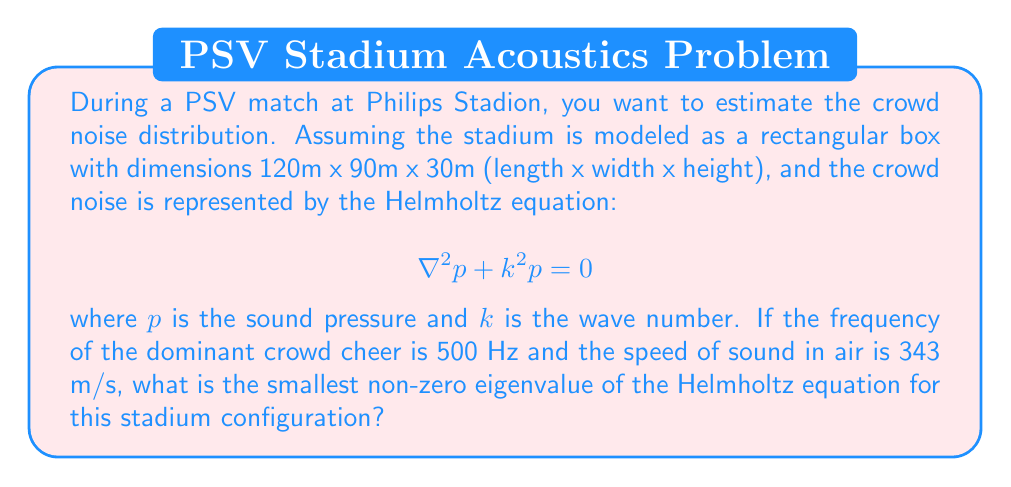Teach me how to tackle this problem. To solve this problem, we need to follow these steps:

1) First, we need to calculate the wave number $k$:
   $k = \frac{2\pi f}{c}$, where $f$ is the frequency and $c$ is the speed of sound
   $k = \frac{2\pi (500)}{343} \approx 9.16$ m^(-1)

2) The general solution for the Helmholtz equation in a rectangular box is:
   $$p(x,y,z) = A \cos(\frac{n_x \pi x}{L_x}) \cos(\frac{n_y \pi y}{L_y}) \cos(\frac{n_z \pi z}{L_z})$$
   where $L_x$, $L_y$, and $L_z$ are the dimensions of the box, and $n_x$, $n_y$, and $n_z$ are non-negative integers.

3) The eigenvalues are given by:
   $$k^2 = (\frac{n_x \pi}{L_x})^2 + (\frac{n_y \pi}{L_y})^2 + (\frac{n_z \pi}{L_z})^2$$

4) The smallest non-zero eigenvalue will occur when two of $n_x$, $n_y$, and $n_z$ are 0, and the other is 1. Since $L_z$ (height) is the smallest dimension, the smallest eigenvalue will occur when $n_z = 1$ and $n_x = n_y = 0$.

5) Therefore, the smallest non-zero eigenvalue is:
   $$k^2 = (\frac{\pi}{L_z})^2 = (\frac{\pi}{30})^2 \approx 0.0109$$ m^(-2)

6) Taking the square root:
   $$k = \frac{\pi}{30} \approx 0.1047$$ m^(-1)
Answer: The smallest non-zero eigenvalue of the Helmholtz equation for the given stadium configuration is approximately 0.1047 m^(-1). 